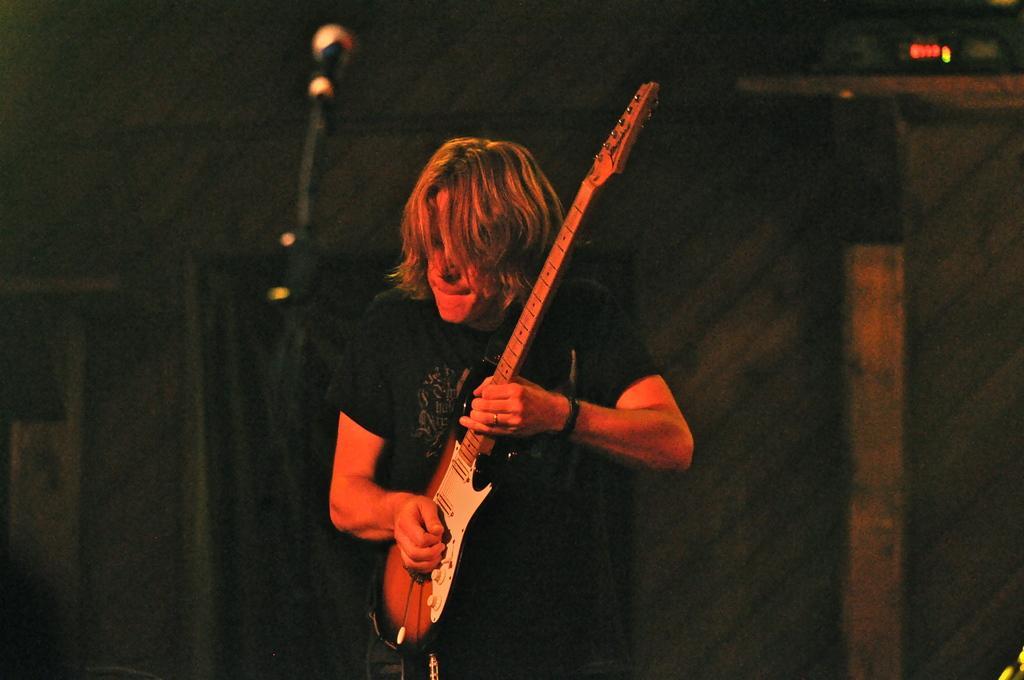Can you describe this image briefly? In the image there is a man playing a guitar and the background of the man is blur. 